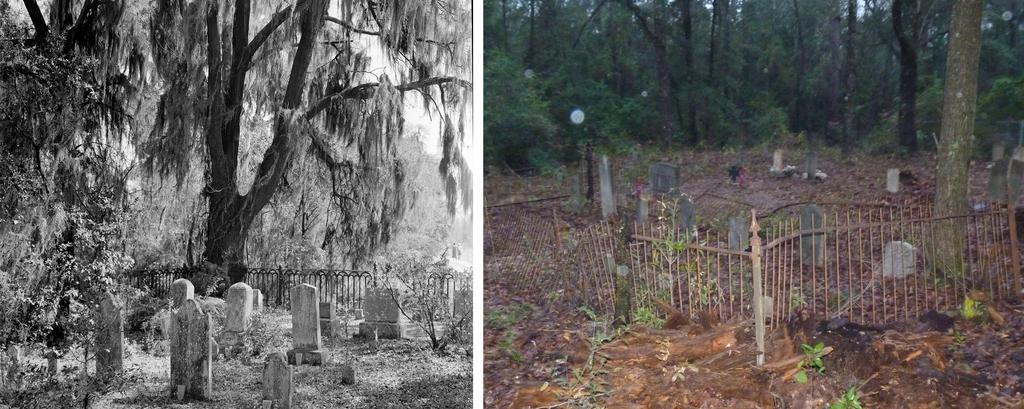How would you summarize this image in a sentence or two? This is a collage image, in this image there are headstones, trees and metal rod fence. 